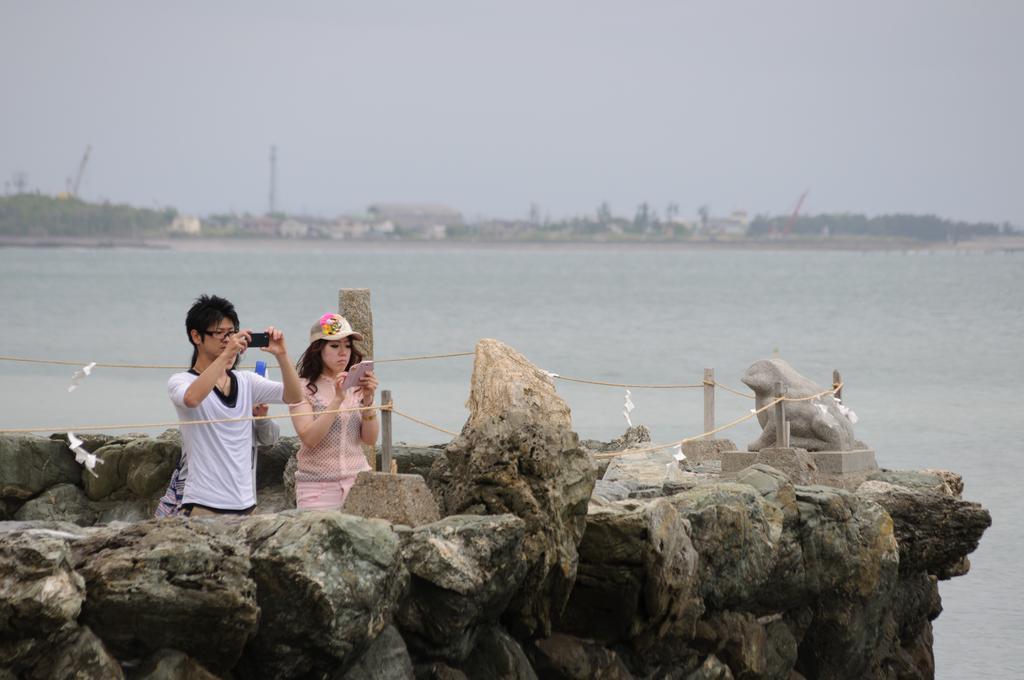Could you give a brief overview of what you see in this image? These people are holding mobiles. In-front of them there are rocks and statue. Background there are trees and water. 